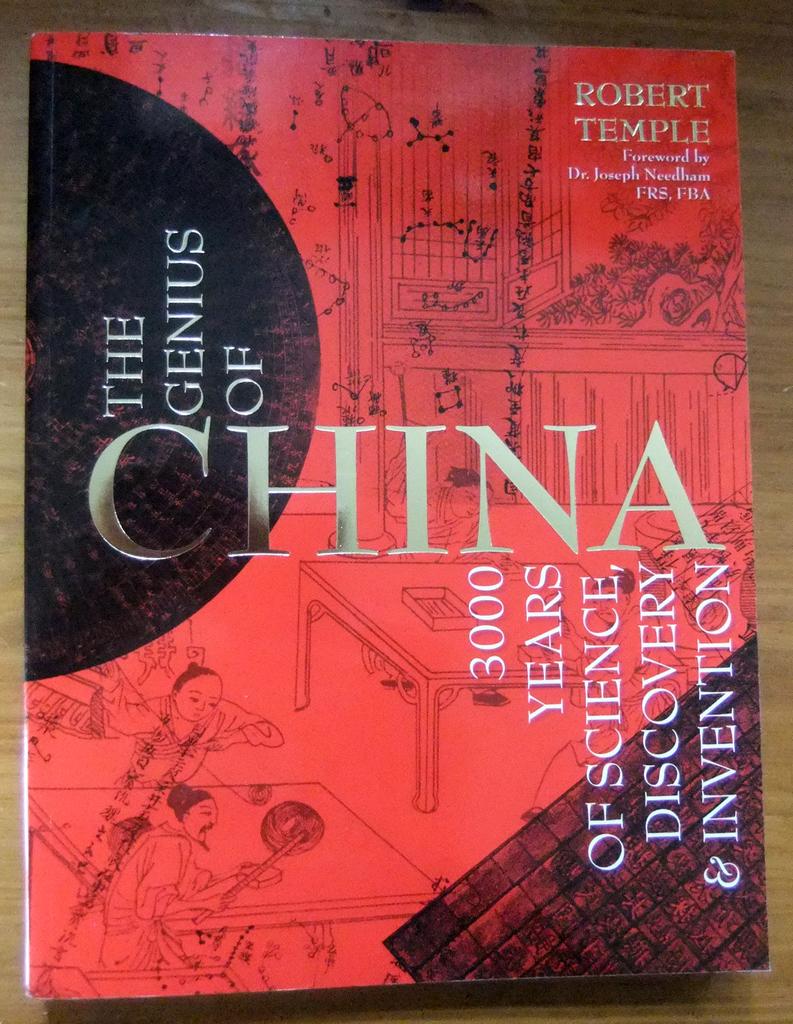What country is this book talking about?
Your answer should be compact. China. How many years of science is mentioned on the book?
Make the answer very short. 3000. 